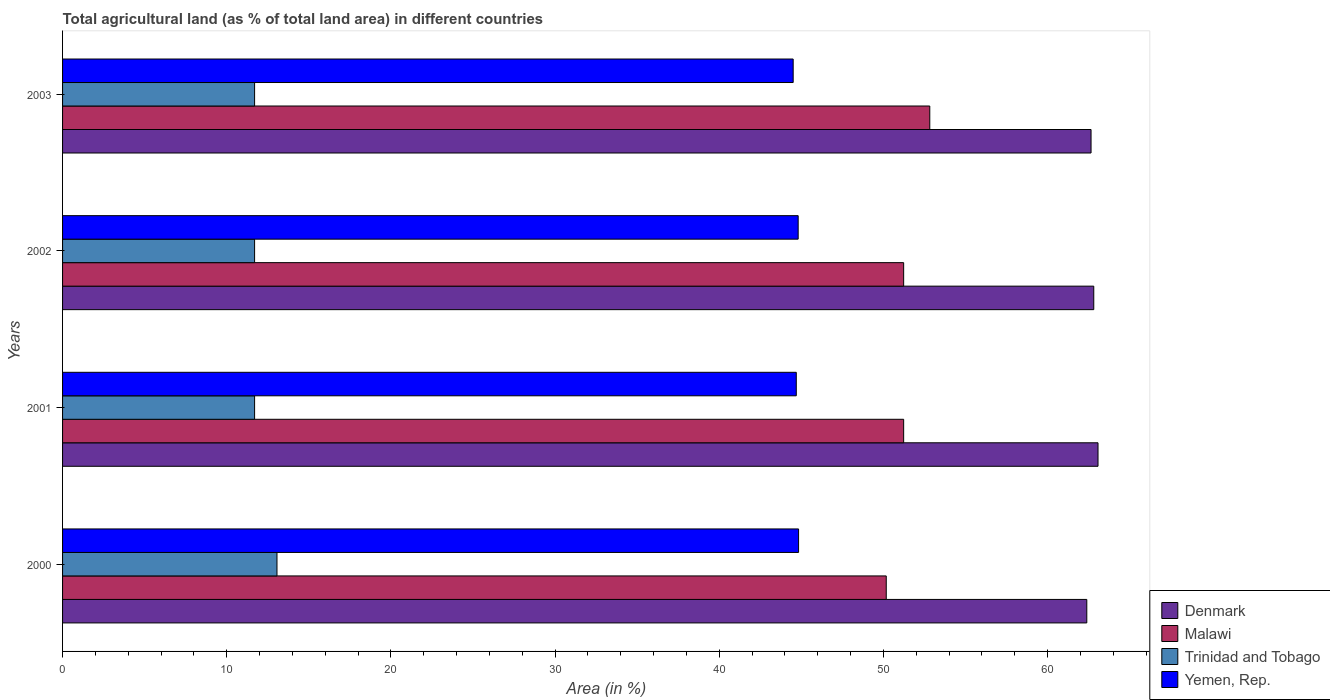Are the number of bars per tick equal to the number of legend labels?
Your answer should be compact. Yes. Are the number of bars on each tick of the Y-axis equal?
Keep it short and to the point. Yes. How many bars are there on the 2nd tick from the bottom?
Your response must be concise. 4. What is the label of the 4th group of bars from the top?
Make the answer very short. 2000. What is the percentage of agricultural land in Denmark in 2002?
Your response must be concise. 62.81. Across all years, what is the maximum percentage of agricultural land in Yemen, Rep.?
Provide a succinct answer. 44.83. Across all years, what is the minimum percentage of agricultural land in Malawi?
Make the answer very short. 50.17. In which year was the percentage of agricultural land in Malawi minimum?
Provide a short and direct response. 2000. What is the total percentage of agricultural land in Yemen, Rep. in the graph?
Provide a short and direct response. 178.83. What is the difference between the percentage of agricultural land in Denmark in 2000 and that in 2001?
Make the answer very short. -0.68. What is the difference between the percentage of agricultural land in Denmark in 2001 and the percentage of agricultural land in Malawi in 2003?
Provide a short and direct response. 10.25. What is the average percentage of agricultural land in Yemen, Rep. per year?
Keep it short and to the point. 44.71. In the year 2000, what is the difference between the percentage of agricultural land in Yemen, Rep. and percentage of agricultural land in Denmark?
Ensure brevity in your answer.  -17.55. In how many years, is the percentage of agricultural land in Denmark greater than 60 %?
Provide a short and direct response. 4. What is the ratio of the percentage of agricultural land in Denmark in 2000 to that in 2001?
Provide a succinct answer. 0.99. Is the difference between the percentage of agricultural land in Yemen, Rep. in 2000 and 2001 greater than the difference between the percentage of agricultural land in Denmark in 2000 and 2001?
Your response must be concise. Yes. What is the difference between the highest and the second highest percentage of agricultural land in Yemen, Rep.?
Provide a succinct answer. 0.02. What is the difference between the highest and the lowest percentage of agricultural land in Denmark?
Your answer should be compact. 0.68. In how many years, is the percentage of agricultural land in Malawi greater than the average percentage of agricultural land in Malawi taken over all years?
Make the answer very short. 1. What does the 4th bar from the top in 2000 represents?
Give a very brief answer. Denmark. What does the 3rd bar from the bottom in 2003 represents?
Keep it short and to the point. Trinidad and Tobago. How many bars are there?
Ensure brevity in your answer.  16. Are all the bars in the graph horizontal?
Give a very brief answer. Yes. What is the difference between two consecutive major ticks on the X-axis?
Offer a very short reply. 10. Are the values on the major ticks of X-axis written in scientific E-notation?
Your answer should be very brief. No. Does the graph contain grids?
Provide a succinct answer. No. How are the legend labels stacked?
Your answer should be compact. Vertical. What is the title of the graph?
Offer a terse response. Total agricultural land (as % of total land area) in different countries. Does "Sweden" appear as one of the legend labels in the graph?
Keep it short and to the point. No. What is the label or title of the X-axis?
Provide a succinct answer. Area (in %). What is the Area (in %) in Denmark in 2000?
Your response must be concise. 62.39. What is the Area (in %) of Malawi in 2000?
Provide a short and direct response. 50.17. What is the Area (in %) of Trinidad and Tobago in 2000?
Provide a succinct answer. 13.06. What is the Area (in %) of Yemen, Rep. in 2000?
Offer a terse response. 44.83. What is the Area (in %) of Denmark in 2001?
Your response must be concise. 63.07. What is the Area (in %) in Malawi in 2001?
Keep it short and to the point. 51.23. What is the Area (in %) of Trinidad and Tobago in 2001?
Provide a succinct answer. 11.7. What is the Area (in %) in Yemen, Rep. in 2001?
Provide a succinct answer. 44.69. What is the Area (in %) in Denmark in 2002?
Provide a succinct answer. 62.81. What is the Area (in %) of Malawi in 2002?
Your answer should be very brief. 51.23. What is the Area (in %) of Trinidad and Tobago in 2002?
Give a very brief answer. 11.7. What is the Area (in %) of Yemen, Rep. in 2002?
Offer a very short reply. 44.81. What is the Area (in %) in Denmark in 2003?
Your response must be concise. 62.64. What is the Area (in %) of Malawi in 2003?
Give a very brief answer. 52.82. What is the Area (in %) of Trinidad and Tobago in 2003?
Keep it short and to the point. 11.7. What is the Area (in %) of Yemen, Rep. in 2003?
Offer a terse response. 44.5. Across all years, what is the maximum Area (in %) in Denmark?
Ensure brevity in your answer.  63.07. Across all years, what is the maximum Area (in %) in Malawi?
Your answer should be compact. 52.82. Across all years, what is the maximum Area (in %) in Trinidad and Tobago?
Give a very brief answer. 13.06. Across all years, what is the maximum Area (in %) of Yemen, Rep.?
Offer a terse response. 44.83. Across all years, what is the minimum Area (in %) in Denmark?
Keep it short and to the point. 62.39. Across all years, what is the minimum Area (in %) in Malawi?
Provide a short and direct response. 50.17. Across all years, what is the minimum Area (in %) of Trinidad and Tobago?
Give a very brief answer. 11.7. Across all years, what is the minimum Area (in %) in Yemen, Rep.?
Make the answer very short. 44.5. What is the total Area (in %) in Denmark in the graph?
Ensure brevity in your answer.  250.91. What is the total Area (in %) in Malawi in the graph?
Offer a very short reply. 205.45. What is the total Area (in %) of Trinidad and Tobago in the graph?
Offer a terse response. 48.15. What is the total Area (in %) of Yemen, Rep. in the graph?
Your response must be concise. 178.83. What is the difference between the Area (in %) in Denmark in 2000 and that in 2001?
Your answer should be compact. -0.68. What is the difference between the Area (in %) of Malawi in 2000 and that in 2001?
Provide a short and direct response. -1.06. What is the difference between the Area (in %) of Trinidad and Tobago in 2000 and that in 2001?
Make the answer very short. 1.36. What is the difference between the Area (in %) in Yemen, Rep. in 2000 and that in 2001?
Make the answer very short. 0.14. What is the difference between the Area (in %) in Denmark in 2000 and that in 2002?
Provide a succinct answer. -0.42. What is the difference between the Area (in %) in Malawi in 2000 and that in 2002?
Offer a terse response. -1.06. What is the difference between the Area (in %) in Trinidad and Tobago in 2000 and that in 2002?
Offer a terse response. 1.36. What is the difference between the Area (in %) of Yemen, Rep. in 2000 and that in 2002?
Offer a very short reply. 0.02. What is the difference between the Area (in %) of Denmark in 2000 and that in 2003?
Provide a short and direct response. -0.26. What is the difference between the Area (in %) of Malawi in 2000 and that in 2003?
Give a very brief answer. -2.65. What is the difference between the Area (in %) in Trinidad and Tobago in 2000 and that in 2003?
Provide a succinct answer. 1.36. What is the difference between the Area (in %) of Yemen, Rep. in 2000 and that in 2003?
Give a very brief answer. 0.33. What is the difference between the Area (in %) in Denmark in 2001 and that in 2002?
Keep it short and to the point. 0.26. What is the difference between the Area (in %) in Malawi in 2001 and that in 2002?
Give a very brief answer. 0. What is the difference between the Area (in %) in Yemen, Rep. in 2001 and that in 2002?
Make the answer very short. -0.12. What is the difference between the Area (in %) in Denmark in 2001 and that in 2003?
Offer a very short reply. 0.42. What is the difference between the Area (in %) of Malawi in 2001 and that in 2003?
Give a very brief answer. -1.59. What is the difference between the Area (in %) in Trinidad and Tobago in 2001 and that in 2003?
Your response must be concise. 0. What is the difference between the Area (in %) of Yemen, Rep. in 2001 and that in 2003?
Give a very brief answer. 0.19. What is the difference between the Area (in %) in Denmark in 2002 and that in 2003?
Make the answer very short. 0.17. What is the difference between the Area (in %) of Malawi in 2002 and that in 2003?
Provide a short and direct response. -1.59. What is the difference between the Area (in %) in Yemen, Rep. in 2002 and that in 2003?
Ensure brevity in your answer.  0.3. What is the difference between the Area (in %) of Denmark in 2000 and the Area (in %) of Malawi in 2001?
Provide a short and direct response. 11.15. What is the difference between the Area (in %) of Denmark in 2000 and the Area (in %) of Trinidad and Tobago in 2001?
Ensure brevity in your answer.  50.69. What is the difference between the Area (in %) in Denmark in 2000 and the Area (in %) in Yemen, Rep. in 2001?
Your response must be concise. 17.7. What is the difference between the Area (in %) of Malawi in 2000 and the Area (in %) of Trinidad and Tobago in 2001?
Provide a succinct answer. 38.47. What is the difference between the Area (in %) of Malawi in 2000 and the Area (in %) of Yemen, Rep. in 2001?
Keep it short and to the point. 5.48. What is the difference between the Area (in %) of Trinidad and Tobago in 2000 and the Area (in %) of Yemen, Rep. in 2001?
Keep it short and to the point. -31.63. What is the difference between the Area (in %) in Denmark in 2000 and the Area (in %) in Malawi in 2002?
Keep it short and to the point. 11.15. What is the difference between the Area (in %) in Denmark in 2000 and the Area (in %) in Trinidad and Tobago in 2002?
Keep it short and to the point. 50.69. What is the difference between the Area (in %) in Denmark in 2000 and the Area (in %) in Yemen, Rep. in 2002?
Your response must be concise. 17.58. What is the difference between the Area (in %) of Malawi in 2000 and the Area (in %) of Trinidad and Tobago in 2002?
Offer a terse response. 38.47. What is the difference between the Area (in %) in Malawi in 2000 and the Area (in %) in Yemen, Rep. in 2002?
Keep it short and to the point. 5.36. What is the difference between the Area (in %) of Trinidad and Tobago in 2000 and the Area (in %) of Yemen, Rep. in 2002?
Your answer should be very brief. -31.75. What is the difference between the Area (in %) of Denmark in 2000 and the Area (in %) of Malawi in 2003?
Keep it short and to the point. 9.56. What is the difference between the Area (in %) in Denmark in 2000 and the Area (in %) in Trinidad and Tobago in 2003?
Make the answer very short. 50.69. What is the difference between the Area (in %) in Denmark in 2000 and the Area (in %) in Yemen, Rep. in 2003?
Ensure brevity in your answer.  17.88. What is the difference between the Area (in %) in Malawi in 2000 and the Area (in %) in Trinidad and Tobago in 2003?
Provide a succinct answer. 38.47. What is the difference between the Area (in %) in Malawi in 2000 and the Area (in %) in Yemen, Rep. in 2003?
Provide a short and direct response. 5.67. What is the difference between the Area (in %) in Trinidad and Tobago in 2000 and the Area (in %) in Yemen, Rep. in 2003?
Keep it short and to the point. -31.44. What is the difference between the Area (in %) in Denmark in 2001 and the Area (in %) in Malawi in 2002?
Your response must be concise. 11.84. What is the difference between the Area (in %) in Denmark in 2001 and the Area (in %) in Trinidad and Tobago in 2002?
Make the answer very short. 51.37. What is the difference between the Area (in %) in Denmark in 2001 and the Area (in %) in Yemen, Rep. in 2002?
Your answer should be compact. 18.26. What is the difference between the Area (in %) in Malawi in 2001 and the Area (in %) in Trinidad and Tobago in 2002?
Keep it short and to the point. 39.53. What is the difference between the Area (in %) in Malawi in 2001 and the Area (in %) in Yemen, Rep. in 2002?
Ensure brevity in your answer.  6.42. What is the difference between the Area (in %) of Trinidad and Tobago in 2001 and the Area (in %) of Yemen, Rep. in 2002?
Your answer should be very brief. -33.11. What is the difference between the Area (in %) in Denmark in 2001 and the Area (in %) in Malawi in 2003?
Provide a succinct answer. 10.25. What is the difference between the Area (in %) of Denmark in 2001 and the Area (in %) of Trinidad and Tobago in 2003?
Your answer should be very brief. 51.37. What is the difference between the Area (in %) in Denmark in 2001 and the Area (in %) in Yemen, Rep. in 2003?
Your answer should be very brief. 18.57. What is the difference between the Area (in %) of Malawi in 2001 and the Area (in %) of Trinidad and Tobago in 2003?
Ensure brevity in your answer.  39.53. What is the difference between the Area (in %) of Malawi in 2001 and the Area (in %) of Yemen, Rep. in 2003?
Provide a succinct answer. 6.73. What is the difference between the Area (in %) in Trinidad and Tobago in 2001 and the Area (in %) in Yemen, Rep. in 2003?
Provide a short and direct response. -32.8. What is the difference between the Area (in %) of Denmark in 2002 and the Area (in %) of Malawi in 2003?
Give a very brief answer. 9.99. What is the difference between the Area (in %) of Denmark in 2002 and the Area (in %) of Trinidad and Tobago in 2003?
Offer a very short reply. 51.11. What is the difference between the Area (in %) in Denmark in 2002 and the Area (in %) in Yemen, Rep. in 2003?
Ensure brevity in your answer.  18.31. What is the difference between the Area (in %) in Malawi in 2002 and the Area (in %) in Trinidad and Tobago in 2003?
Your answer should be compact. 39.53. What is the difference between the Area (in %) of Malawi in 2002 and the Area (in %) of Yemen, Rep. in 2003?
Offer a very short reply. 6.73. What is the difference between the Area (in %) in Trinidad and Tobago in 2002 and the Area (in %) in Yemen, Rep. in 2003?
Offer a very short reply. -32.8. What is the average Area (in %) of Denmark per year?
Offer a terse response. 62.73. What is the average Area (in %) of Malawi per year?
Provide a succinct answer. 51.36. What is the average Area (in %) in Trinidad and Tobago per year?
Provide a succinct answer. 12.04. What is the average Area (in %) in Yemen, Rep. per year?
Offer a terse response. 44.71. In the year 2000, what is the difference between the Area (in %) in Denmark and Area (in %) in Malawi?
Your response must be concise. 12.22. In the year 2000, what is the difference between the Area (in %) in Denmark and Area (in %) in Trinidad and Tobago?
Ensure brevity in your answer.  49.32. In the year 2000, what is the difference between the Area (in %) of Denmark and Area (in %) of Yemen, Rep.?
Make the answer very short. 17.55. In the year 2000, what is the difference between the Area (in %) of Malawi and Area (in %) of Trinidad and Tobago?
Ensure brevity in your answer.  37.11. In the year 2000, what is the difference between the Area (in %) in Malawi and Area (in %) in Yemen, Rep.?
Keep it short and to the point. 5.34. In the year 2000, what is the difference between the Area (in %) of Trinidad and Tobago and Area (in %) of Yemen, Rep.?
Your response must be concise. -31.77. In the year 2001, what is the difference between the Area (in %) in Denmark and Area (in %) in Malawi?
Offer a very short reply. 11.84. In the year 2001, what is the difference between the Area (in %) of Denmark and Area (in %) of Trinidad and Tobago?
Provide a succinct answer. 51.37. In the year 2001, what is the difference between the Area (in %) in Denmark and Area (in %) in Yemen, Rep.?
Keep it short and to the point. 18.38. In the year 2001, what is the difference between the Area (in %) of Malawi and Area (in %) of Trinidad and Tobago?
Ensure brevity in your answer.  39.53. In the year 2001, what is the difference between the Area (in %) of Malawi and Area (in %) of Yemen, Rep.?
Make the answer very short. 6.54. In the year 2001, what is the difference between the Area (in %) of Trinidad and Tobago and Area (in %) of Yemen, Rep.?
Your answer should be compact. -32.99. In the year 2002, what is the difference between the Area (in %) in Denmark and Area (in %) in Malawi?
Offer a terse response. 11.58. In the year 2002, what is the difference between the Area (in %) in Denmark and Area (in %) in Trinidad and Tobago?
Provide a succinct answer. 51.11. In the year 2002, what is the difference between the Area (in %) in Denmark and Area (in %) in Yemen, Rep.?
Your answer should be compact. 18. In the year 2002, what is the difference between the Area (in %) in Malawi and Area (in %) in Trinidad and Tobago?
Make the answer very short. 39.53. In the year 2002, what is the difference between the Area (in %) of Malawi and Area (in %) of Yemen, Rep.?
Keep it short and to the point. 6.42. In the year 2002, what is the difference between the Area (in %) of Trinidad and Tobago and Area (in %) of Yemen, Rep.?
Provide a succinct answer. -33.11. In the year 2003, what is the difference between the Area (in %) in Denmark and Area (in %) in Malawi?
Ensure brevity in your answer.  9.82. In the year 2003, what is the difference between the Area (in %) of Denmark and Area (in %) of Trinidad and Tobago?
Give a very brief answer. 50.95. In the year 2003, what is the difference between the Area (in %) in Denmark and Area (in %) in Yemen, Rep.?
Make the answer very short. 18.14. In the year 2003, what is the difference between the Area (in %) of Malawi and Area (in %) of Trinidad and Tobago?
Your response must be concise. 41.13. In the year 2003, what is the difference between the Area (in %) in Malawi and Area (in %) in Yemen, Rep.?
Keep it short and to the point. 8.32. In the year 2003, what is the difference between the Area (in %) of Trinidad and Tobago and Area (in %) of Yemen, Rep.?
Provide a succinct answer. -32.8. What is the ratio of the Area (in %) in Denmark in 2000 to that in 2001?
Your answer should be very brief. 0.99. What is the ratio of the Area (in %) of Malawi in 2000 to that in 2001?
Make the answer very short. 0.98. What is the ratio of the Area (in %) of Trinidad and Tobago in 2000 to that in 2001?
Keep it short and to the point. 1.12. What is the ratio of the Area (in %) of Yemen, Rep. in 2000 to that in 2001?
Offer a very short reply. 1. What is the ratio of the Area (in %) in Denmark in 2000 to that in 2002?
Keep it short and to the point. 0.99. What is the ratio of the Area (in %) in Malawi in 2000 to that in 2002?
Your response must be concise. 0.98. What is the ratio of the Area (in %) in Trinidad and Tobago in 2000 to that in 2002?
Offer a very short reply. 1.12. What is the ratio of the Area (in %) of Malawi in 2000 to that in 2003?
Provide a succinct answer. 0.95. What is the ratio of the Area (in %) in Trinidad and Tobago in 2000 to that in 2003?
Your answer should be compact. 1.12. What is the ratio of the Area (in %) in Yemen, Rep. in 2000 to that in 2003?
Provide a succinct answer. 1.01. What is the ratio of the Area (in %) in Denmark in 2001 to that in 2002?
Offer a very short reply. 1. What is the ratio of the Area (in %) of Trinidad and Tobago in 2001 to that in 2002?
Offer a very short reply. 1. What is the ratio of the Area (in %) in Denmark in 2001 to that in 2003?
Keep it short and to the point. 1.01. What is the ratio of the Area (in %) in Malawi in 2001 to that in 2003?
Offer a terse response. 0.97. What is the ratio of the Area (in %) of Trinidad and Tobago in 2001 to that in 2003?
Give a very brief answer. 1. What is the ratio of the Area (in %) of Denmark in 2002 to that in 2003?
Your response must be concise. 1. What is the ratio of the Area (in %) of Malawi in 2002 to that in 2003?
Your response must be concise. 0.97. What is the ratio of the Area (in %) of Trinidad and Tobago in 2002 to that in 2003?
Your answer should be compact. 1. What is the ratio of the Area (in %) of Yemen, Rep. in 2002 to that in 2003?
Provide a succinct answer. 1.01. What is the difference between the highest and the second highest Area (in %) of Denmark?
Your answer should be very brief. 0.26. What is the difference between the highest and the second highest Area (in %) in Malawi?
Your answer should be very brief. 1.59. What is the difference between the highest and the second highest Area (in %) in Trinidad and Tobago?
Offer a very short reply. 1.36. What is the difference between the highest and the second highest Area (in %) in Yemen, Rep.?
Your answer should be very brief. 0.02. What is the difference between the highest and the lowest Area (in %) in Denmark?
Keep it short and to the point. 0.68. What is the difference between the highest and the lowest Area (in %) in Malawi?
Your answer should be very brief. 2.65. What is the difference between the highest and the lowest Area (in %) in Trinidad and Tobago?
Provide a succinct answer. 1.36. What is the difference between the highest and the lowest Area (in %) in Yemen, Rep.?
Offer a very short reply. 0.33. 